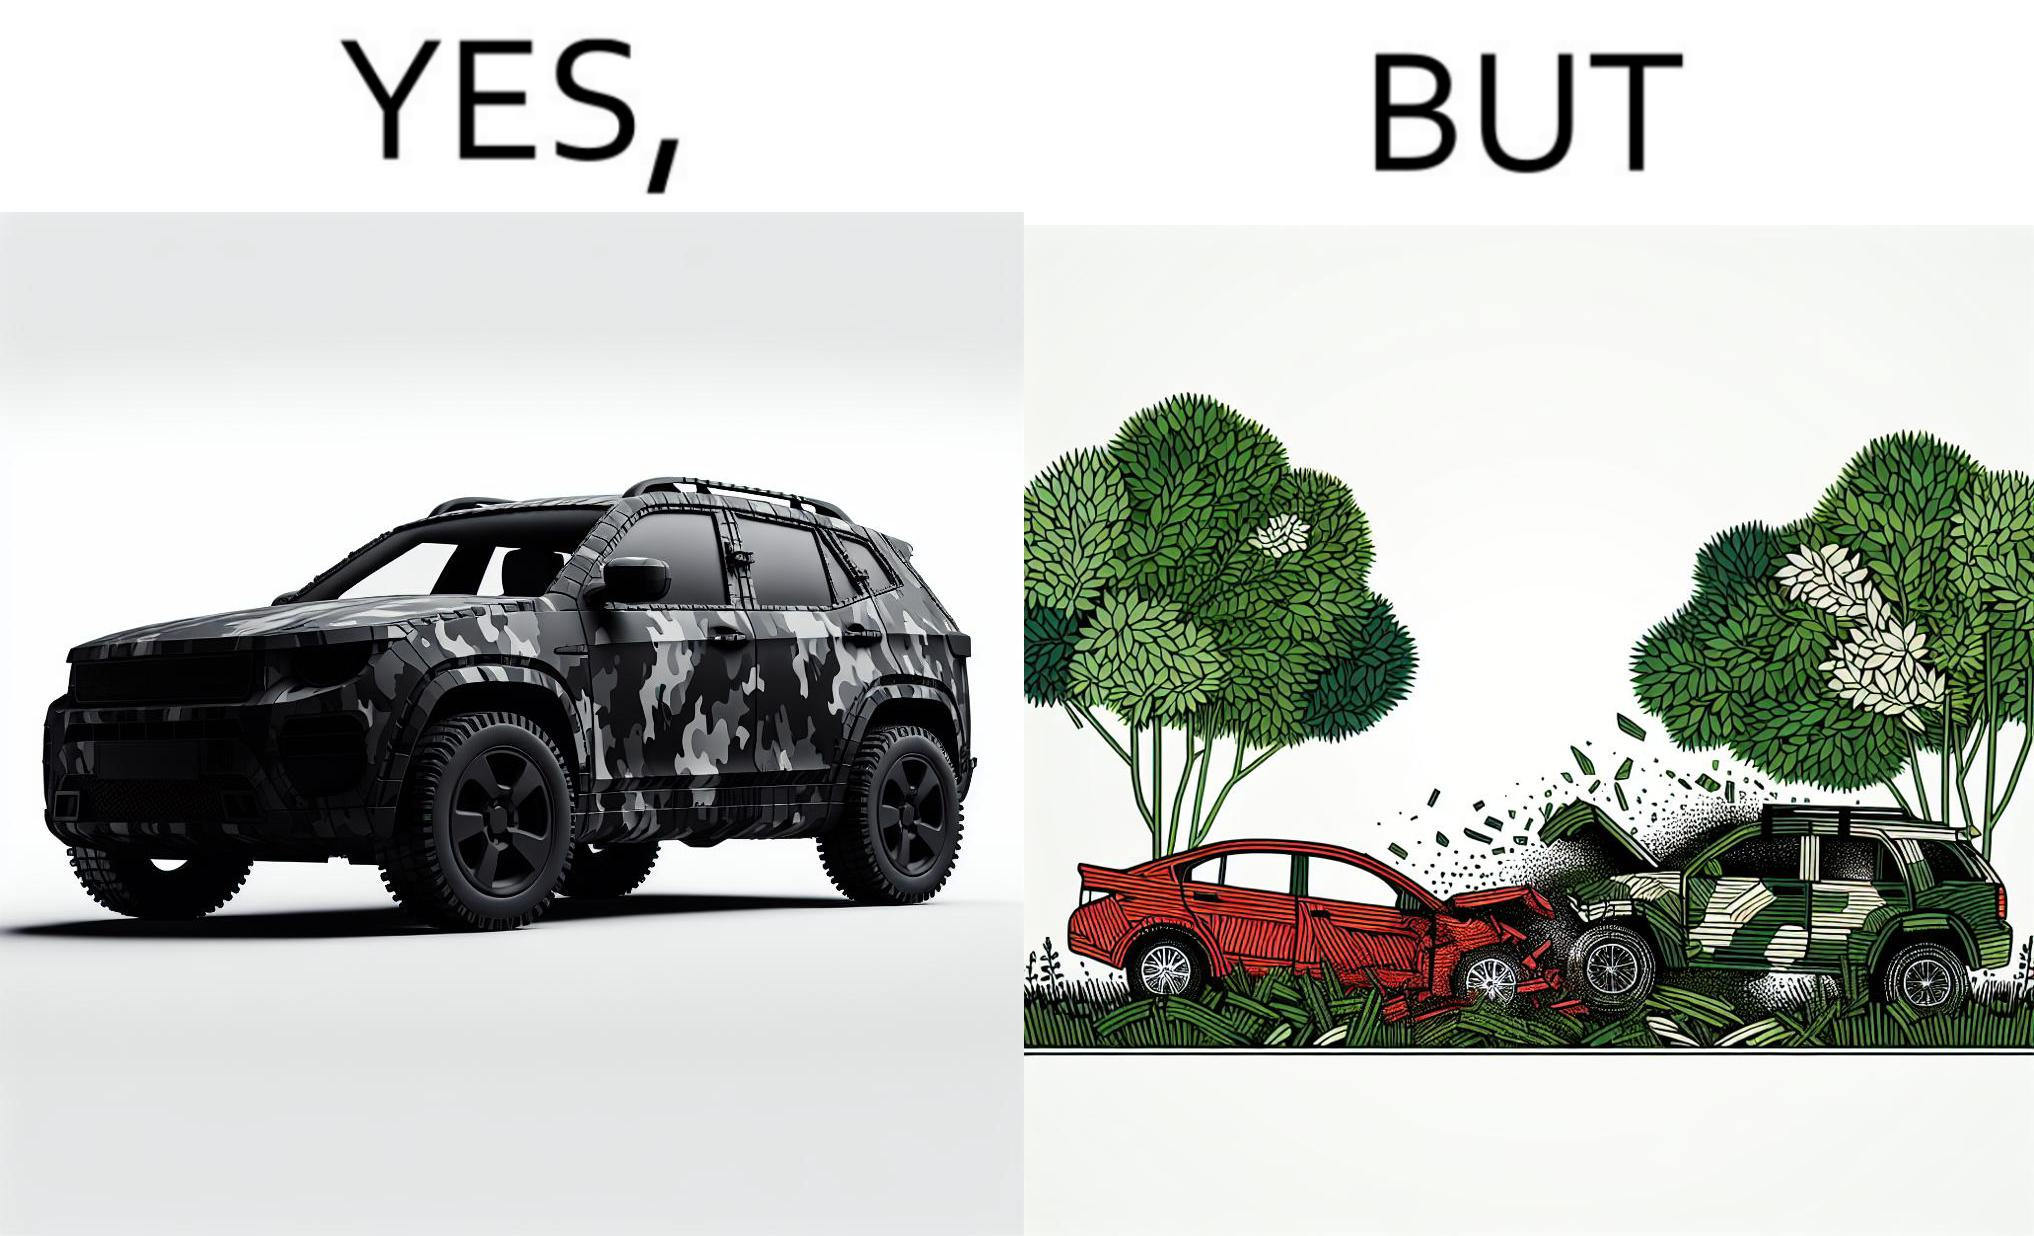Describe what you see in this image. The image is ironic, because in the left image a car is painted in camouflage color but in the right image the same car is getting involved in accident to due to its color as other drivers face difficulty in recognizing the colors 